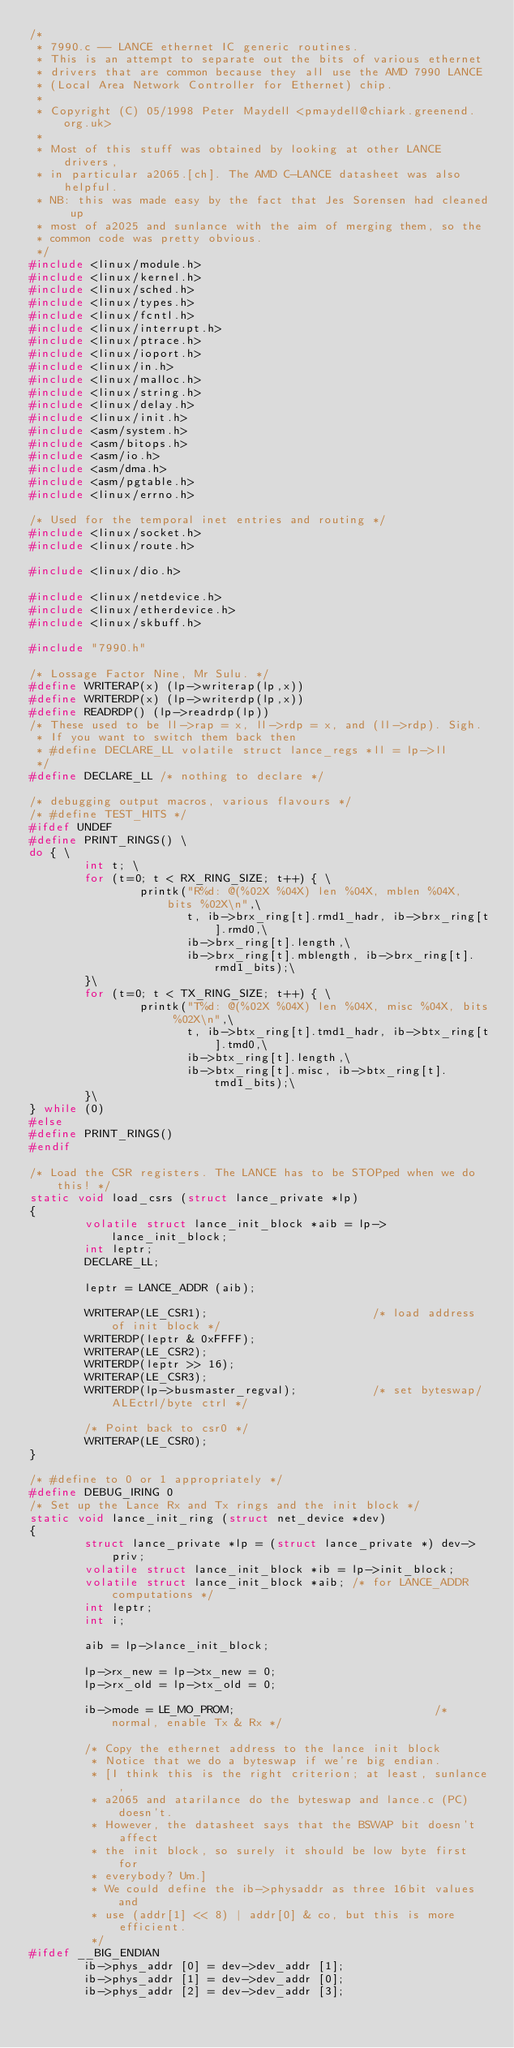Convert code to text. <code><loc_0><loc_0><loc_500><loc_500><_C_>/* 
 * 7990.c -- LANCE ethernet IC generic routines. 
 * This is an attempt to separate out the bits of various ethernet
 * drivers that are common because they all use the AMD 7990 LANCE 
 * (Local Area Network Controller for Ethernet) chip.
 *
 * Copyright (C) 05/1998 Peter Maydell <pmaydell@chiark.greenend.org.uk>
 *
 * Most of this stuff was obtained by looking at other LANCE drivers,
 * in particular a2065.[ch]. The AMD C-LANCE datasheet was also helpful.
 * NB: this was made easy by the fact that Jes Sorensen had cleaned up
 * most of a2025 and sunlance with the aim of merging them, so the 
 * common code was pretty obvious.
 */
#include <linux/module.h>
#include <linux/kernel.h>
#include <linux/sched.h>
#include <linux/types.h>
#include <linux/fcntl.h>
#include <linux/interrupt.h>
#include <linux/ptrace.h>
#include <linux/ioport.h>
#include <linux/in.h>
#include <linux/malloc.h>
#include <linux/string.h>
#include <linux/delay.h>
#include <linux/init.h>
#include <asm/system.h>
#include <asm/bitops.h>
#include <asm/io.h>
#include <asm/dma.h>
#include <asm/pgtable.h>
#include <linux/errno.h>

/* Used for the temporal inet entries and routing */
#include <linux/socket.h>
#include <linux/route.h>

#include <linux/dio.h>

#include <linux/netdevice.h>
#include <linux/etherdevice.h>
#include <linux/skbuff.h>

#include "7990.h"

/* Lossage Factor Nine, Mr Sulu. */
#define WRITERAP(x) (lp->writerap(lp,x))
#define WRITERDP(x) (lp->writerdp(lp,x))
#define READRDP() (lp->readrdp(lp))
/* These used to be ll->rap = x, ll->rdp = x, and (ll->rdp). Sigh. 
 * If you want to switch them back then 
 * #define DECLARE_LL volatile struct lance_regs *ll = lp->ll
 */
#define DECLARE_LL /* nothing to declare */

/* debugging output macros, various flavours */
/* #define TEST_HITS */
#ifdef UNDEF
#define PRINT_RINGS() \
do { \
        int t; \
        for (t=0; t < RX_RING_SIZE; t++) { \
                printk("R%d: @(%02X %04X) len %04X, mblen %04X, bits %02X\n",\
                       t, ib->brx_ring[t].rmd1_hadr, ib->brx_ring[t].rmd0,\
                       ib->brx_ring[t].length,\
                       ib->brx_ring[t].mblength, ib->brx_ring[t].rmd1_bits);\
        }\
        for (t=0; t < TX_RING_SIZE; t++) { \
                printk("T%d: @(%02X %04X) len %04X, misc %04X, bits %02X\n",\
                       t, ib->btx_ring[t].tmd1_hadr, ib->btx_ring[t].tmd0,\
                       ib->btx_ring[t].length,\
                       ib->btx_ring[t].misc, ib->btx_ring[t].tmd1_bits);\
        }\
} while (0) 
#else
#define PRINT_RINGS()
#endif        

/* Load the CSR registers. The LANCE has to be STOPped when we do this! */
static void load_csrs (struct lance_private *lp)
{
        volatile struct lance_init_block *aib = lp->lance_init_block;
        int leptr;
        DECLARE_LL;

        leptr = LANCE_ADDR (aib);

        WRITERAP(LE_CSR1);                        /* load address of init block */
        WRITERDP(leptr & 0xFFFF);
        WRITERAP(LE_CSR2);
        WRITERDP(leptr >> 16);
        WRITERAP(LE_CSR3);
        WRITERDP(lp->busmaster_regval);           /* set byteswap/ALEctrl/byte ctrl */

        /* Point back to csr0 */
        WRITERAP(LE_CSR0);
}

/* #define to 0 or 1 appropriately */
#define DEBUG_IRING 0
/* Set up the Lance Rx and Tx rings and the init block */
static void lance_init_ring (struct net_device *dev)
{
        struct lance_private *lp = (struct lance_private *) dev->priv;
        volatile struct lance_init_block *ib = lp->init_block;
        volatile struct lance_init_block *aib; /* for LANCE_ADDR computations */
        int leptr;
        int i;

        aib = lp->lance_init_block;

        lp->rx_new = lp->tx_new = 0;
        lp->rx_old = lp->tx_old = 0;

        ib->mode = LE_MO_PROM;                             /* normal, enable Tx & Rx */

        /* Copy the ethernet address to the lance init block
         * Notice that we do a byteswap if we're big endian.
         * [I think this is the right criterion; at least, sunlance,
         * a2065 and atarilance do the byteswap and lance.c (PC) doesn't.
         * However, the datasheet says that the BSWAP bit doesn't affect
         * the init block, so surely it should be low byte first for
         * everybody? Um.] 
         * We could define the ib->physaddr as three 16bit values and
         * use (addr[1] << 8) | addr[0] & co, but this is more efficient.
         */
#ifdef __BIG_ENDIAN
        ib->phys_addr [0] = dev->dev_addr [1];
        ib->phys_addr [1] = dev->dev_addr [0];
        ib->phys_addr [2] = dev->dev_addr [3];</code> 